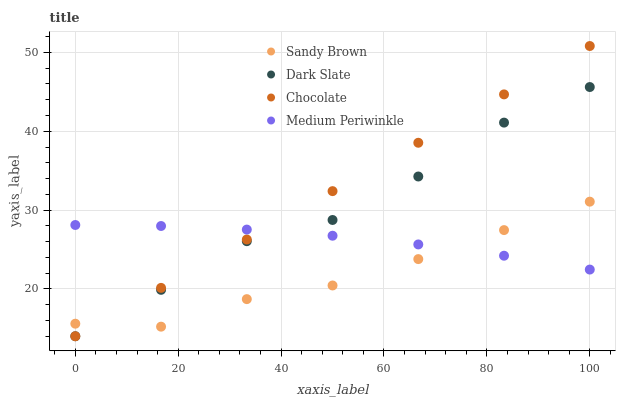Does Sandy Brown have the minimum area under the curve?
Answer yes or no. Yes. Does Chocolate have the maximum area under the curve?
Answer yes or no. Yes. Does Medium Periwinkle have the minimum area under the curve?
Answer yes or no. No. Does Medium Periwinkle have the maximum area under the curve?
Answer yes or no. No. Is Chocolate the smoothest?
Answer yes or no. Yes. Is Dark Slate the roughest?
Answer yes or no. Yes. Is Sandy Brown the smoothest?
Answer yes or no. No. Is Sandy Brown the roughest?
Answer yes or no. No. Does Dark Slate have the lowest value?
Answer yes or no. Yes. Does Sandy Brown have the lowest value?
Answer yes or no. No. Does Chocolate have the highest value?
Answer yes or no. Yes. Does Sandy Brown have the highest value?
Answer yes or no. No. Does Sandy Brown intersect Chocolate?
Answer yes or no. Yes. Is Sandy Brown less than Chocolate?
Answer yes or no. No. Is Sandy Brown greater than Chocolate?
Answer yes or no. No. 